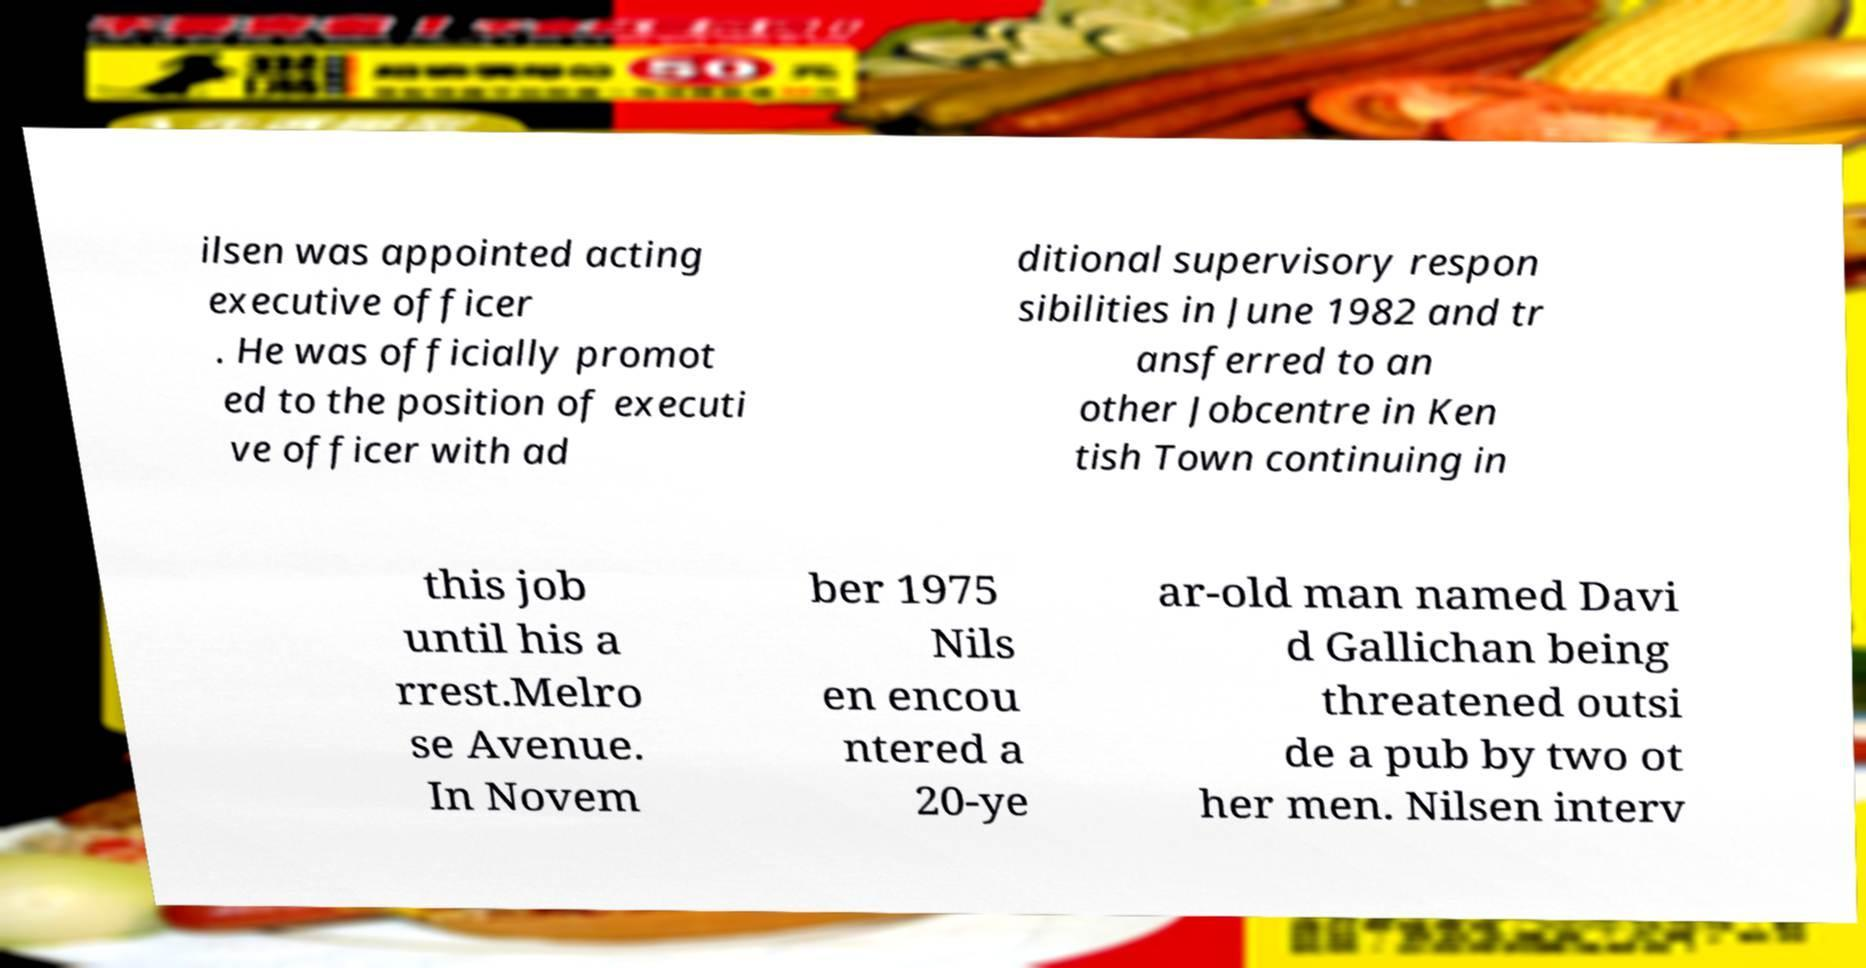Please identify and transcribe the text found in this image. ilsen was appointed acting executive officer . He was officially promot ed to the position of executi ve officer with ad ditional supervisory respon sibilities in June 1982 and tr ansferred to an other Jobcentre in Ken tish Town continuing in this job until his a rrest.Melro se Avenue. In Novem ber 1975 Nils en encou ntered a 20-ye ar-old man named Davi d Gallichan being threatened outsi de a pub by two ot her men. Nilsen interv 